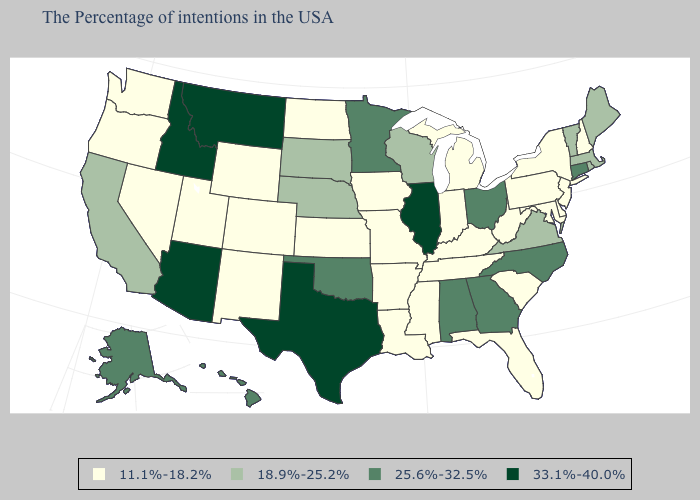What is the lowest value in the USA?
Keep it brief. 11.1%-18.2%. Which states have the lowest value in the USA?
Give a very brief answer. New Hampshire, New York, New Jersey, Delaware, Maryland, Pennsylvania, South Carolina, West Virginia, Florida, Michigan, Kentucky, Indiana, Tennessee, Mississippi, Louisiana, Missouri, Arkansas, Iowa, Kansas, North Dakota, Wyoming, Colorado, New Mexico, Utah, Nevada, Washington, Oregon. Does Montana have the highest value in the USA?
Quick response, please. Yes. What is the value of Georgia?
Short answer required. 25.6%-32.5%. Name the states that have a value in the range 11.1%-18.2%?
Be succinct. New Hampshire, New York, New Jersey, Delaware, Maryland, Pennsylvania, South Carolina, West Virginia, Florida, Michigan, Kentucky, Indiana, Tennessee, Mississippi, Louisiana, Missouri, Arkansas, Iowa, Kansas, North Dakota, Wyoming, Colorado, New Mexico, Utah, Nevada, Washington, Oregon. Among the states that border Connecticut , which have the lowest value?
Give a very brief answer. New York. Which states have the lowest value in the Northeast?
Answer briefly. New Hampshire, New York, New Jersey, Pennsylvania. Which states have the lowest value in the USA?
Answer briefly. New Hampshire, New York, New Jersey, Delaware, Maryland, Pennsylvania, South Carolina, West Virginia, Florida, Michigan, Kentucky, Indiana, Tennessee, Mississippi, Louisiana, Missouri, Arkansas, Iowa, Kansas, North Dakota, Wyoming, Colorado, New Mexico, Utah, Nevada, Washington, Oregon. Among the states that border Illinois , does Wisconsin have the highest value?
Keep it brief. Yes. Among the states that border Kansas , does Nebraska have the lowest value?
Answer briefly. No. Is the legend a continuous bar?
Short answer required. No. Which states hav the highest value in the West?
Short answer required. Montana, Arizona, Idaho. What is the value of Minnesota?
Be succinct. 25.6%-32.5%. Is the legend a continuous bar?
Keep it brief. No. 